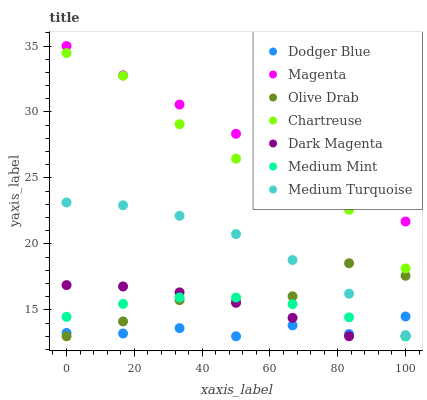Does Dodger Blue have the minimum area under the curve?
Answer yes or no. Yes. Does Magenta have the maximum area under the curve?
Answer yes or no. Yes. Does Dark Magenta have the minimum area under the curve?
Answer yes or no. No. Does Dark Magenta have the maximum area under the curve?
Answer yes or no. No. Is Magenta the smoothest?
Answer yes or no. Yes. Is Olive Drab the roughest?
Answer yes or no. Yes. Is Dark Magenta the smoothest?
Answer yes or no. No. Is Dark Magenta the roughest?
Answer yes or no. No. Does Medium Mint have the lowest value?
Answer yes or no. Yes. Does Chartreuse have the lowest value?
Answer yes or no. No. Does Magenta have the highest value?
Answer yes or no. Yes. Does Dark Magenta have the highest value?
Answer yes or no. No. Is Medium Turquoise less than Magenta?
Answer yes or no. Yes. Is Magenta greater than Medium Turquoise?
Answer yes or no. Yes. Does Dodger Blue intersect Olive Drab?
Answer yes or no. Yes. Is Dodger Blue less than Olive Drab?
Answer yes or no. No. Is Dodger Blue greater than Olive Drab?
Answer yes or no. No. Does Medium Turquoise intersect Magenta?
Answer yes or no. No. 